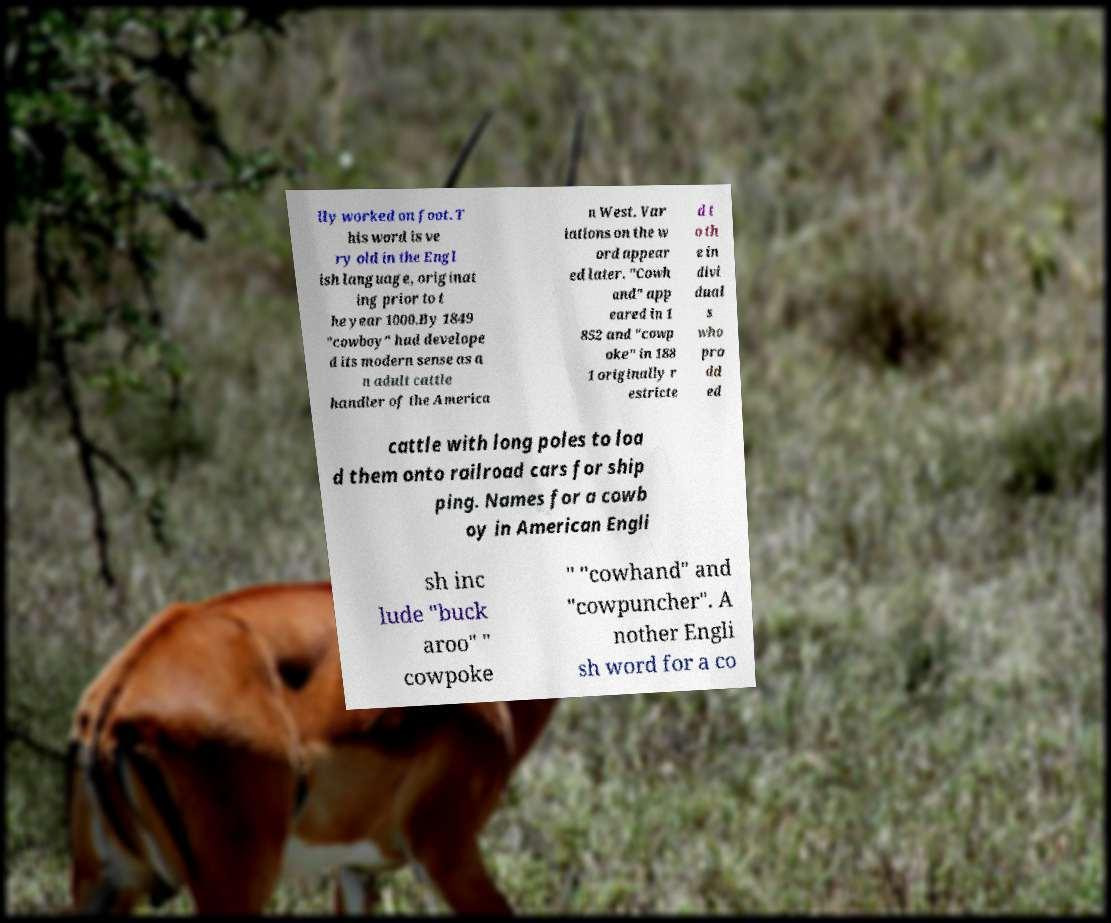Could you assist in decoding the text presented in this image and type it out clearly? lly worked on foot. T his word is ve ry old in the Engl ish language, originat ing prior to t he year 1000.By 1849 "cowboy" had develope d its modern sense as a n adult cattle handler of the America n West. Var iations on the w ord appear ed later. "Cowh and" app eared in 1 852 and "cowp oke" in 188 1 originally r estricte d t o th e in divi dual s who pro dd ed cattle with long poles to loa d them onto railroad cars for ship ping. Names for a cowb oy in American Engli sh inc lude "buck aroo" " cowpoke " "cowhand" and "cowpuncher". A nother Engli sh word for a co 